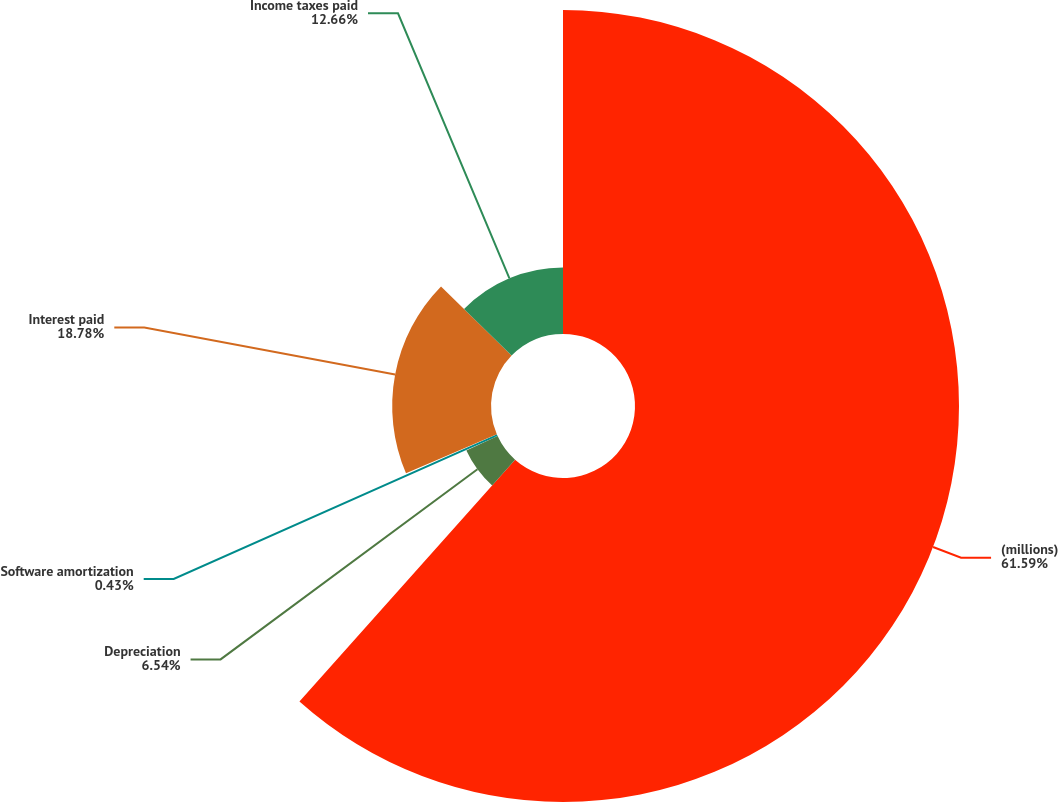Convert chart. <chart><loc_0><loc_0><loc_500><loc_500><pie_chart><fcel>(millions)<fcel>Depreciation<fcel>Software amortization<fcel>Interest paid<fcel>Income taxes paid<nl><fcel>61.59%<fcel>6.54%<fcel>0.43%<fcel>18.78%<fcel>12.66%<nl></chart> 